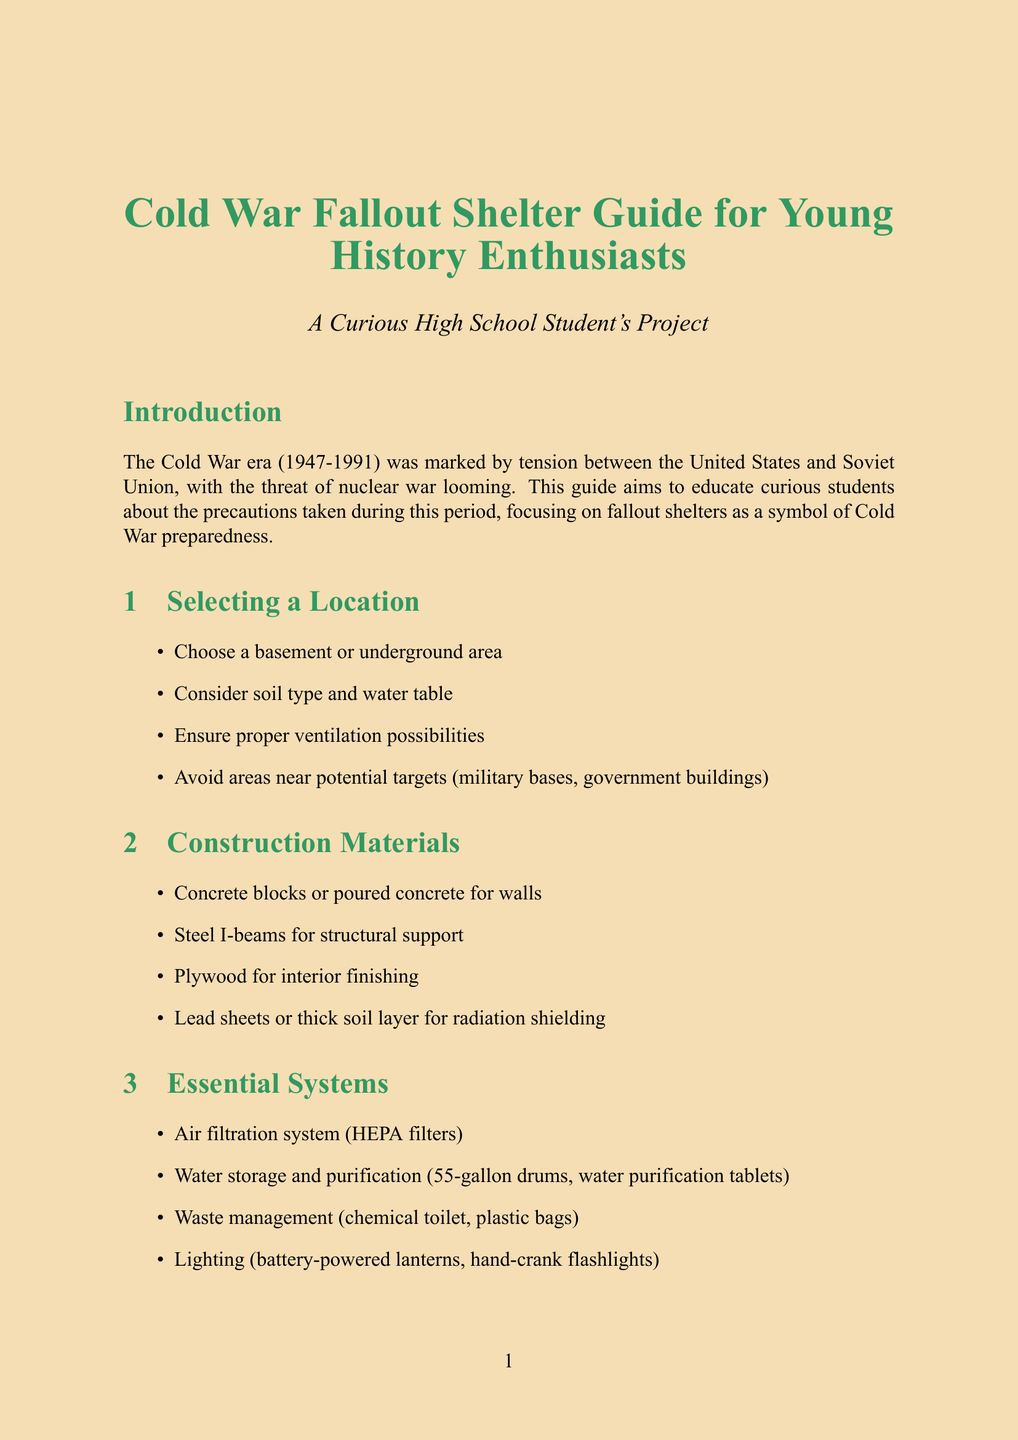What is the title of the guide? The title is the main heading that describes the content of the document.
Answer: Cold War Fallout Shelter Guide for Young History Enthusiasts What is the purpose of the guide? The purpose is stated in the introduction as the reason for creating the document.
Answer: To educate curious students about the precautions taken during this period What chapter discusses essential systems? The chapters are numbered sections that focus on different aspects of fallout shelters.
Answer: Chapter 3 What is one type of construction material mentioned? The content includes lists of materials suggested for building the shelter.
Answer: Concrete blocks How many items are listed in the supply list? The supply list provides a number of essential items for the shelter.
Answer: Five What is one key aspect of shelter maintenance? Maintenance and upkeep require regular checks to ensure everything functions properly.
Answer: Regular inspection of structural integrity What date range defines the Cold War era? The introduction gives historical context to the timeline of the Cold War.
Answer: 1947-1991 What type of items should be stored for entertainment? The document includes recommendations for staying occupied in the shelter.
Answer: Books What is the term for radioactive particles that fall from the sky? The glossary defines specific terms related to fallout shelters.
Answer: Fallout 